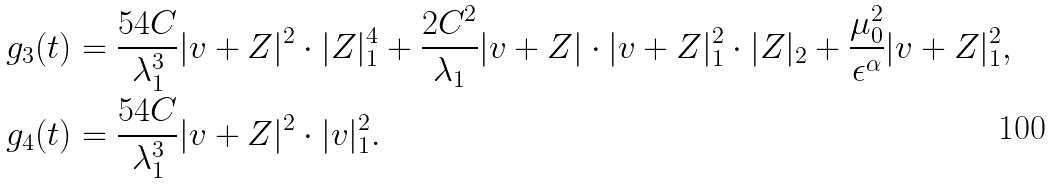Convert formula to latex. <formula><loc_0><loc_0><loc_500><loc_500>g _ { 3 } ( t ) & = \frac { 5 4 C } { \lambda _ { 1 } ^ { 3 } } | v + Z | ^ { 2 } \cdot | Z | _ { 1 } ^ { 4 } + \frac { 2 C ^ { 2 } } { \lambda _ { 1 } } | v + Z | \cdot | v + Z | _ { 1 } ^ { 2 } \cdot | Z | _ { 2 } + \frac { \mu _ { 0 } ^ { 2 } } { \epsilon ^ { \alpha } } | v + Z | _ { 1 } ^ { 2 } , \\ g _ { 4 } ( t ) & = \frac { 5 4 C } { \lambda _ { 1 } ^ { 3 } } | v + Z | ^ { 2 } \cdot | v | _ { 1 } ^ { 2 } .</formula> 